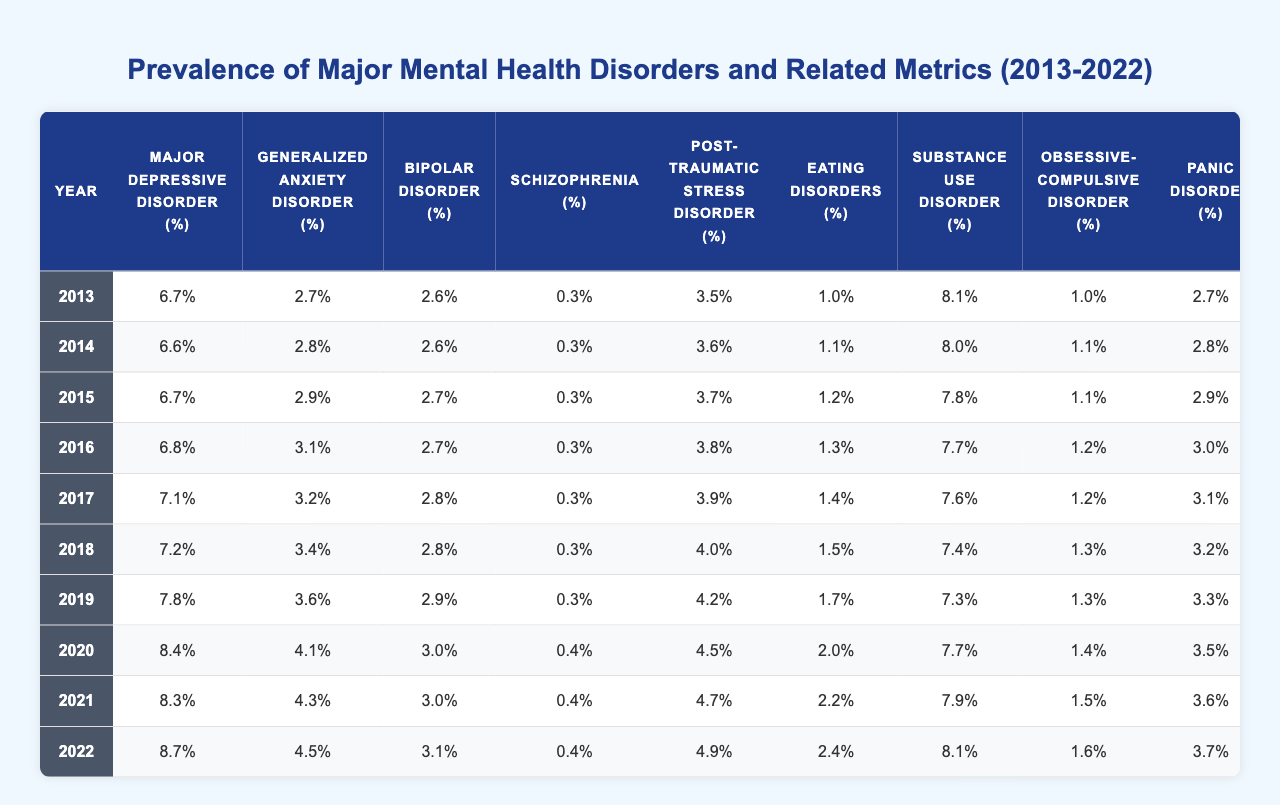What was the prevalence of Major Depressive Disorder in 2022? According to the table, the value for Major Depressive Disorder in 2022 is directly presented as 8.7%.
Answer: 8.7% In which year did Generalized Anxiety Disorder reach its highest prevalence? The table shows that Generalized Anxiety Disorder reached its highest prevalence of 4.5% in 2022.
Answer: 2022 What is the trend of Eating Disorders prevalence from 2013 to 2022? By comparing the values across the years, Eating Disorders increased from 1.0% in 2013 to 2.4% in 2022, indicating a consistent upward trend.
Answer: Increasing What percentage of the population experienced Schizophrenia in 2020? The table indicates that Schizophrenia prevalence was 0.4% in 2020.
Answer: 0.4% What was the average prevalence of Substance Use Disorder over the last decade? To compute the average, we sum the values: (8.1 + 8.0 + 7.8 + 7.7 + 7.6 + 7.4 + 7.3 + 7.7 + 7.9 + 8.1) = 78.6, then divide by 10, yielding an average of 7.86%.
Answer: 7.86% Was there a significant drop in the prevalence of Bipolar Disorder from 2013 to 2018? Reviewing the values from 2013 (2.6%) to 2018 (2.8%), there was no drop; in fact, it increased slightly.
Answer: No What is the difference in the prevalence of Panic Disorder between 2013 and 2022? The prevalence of Panic Disorder was 2.7% in 2013 and 3.7% in 2022. The difference is 3.7% - 2.7% = 1%.
Answer: 1% How many more Mental Health Professionals per 100,000 population were there in 2022 compared to 2013? The number in 2022 was 96, and in 2013 it was 78. The difference is 96 - 78 = 18 professionals per 100,000 population.
Answer: 18 Which mental health disorder had the lowest prevalence in 2019? By checking the table for 2019, the lowest prevalence was for Schizophrenia, at 0.3%.
Answer: Schizophrenia Identify any year where the overall mental health budget experienced a significant increase. Observing the table, the budget increased from 160 million USD in 2019 to 180 million USD in 2020, which is a significant increase of 20 million.
Answer: 2020 What was the percentage increase in prevalence for Generalized Anxiety Disorder from 2015 to 2022? The prevalence in 2015 was 2.9% and in 2022 it is 4.5%. Thus, the increase is 4.5% - 2.9% = 1.6%. To find the percentage increase: (1.6/2.9) * 100 ≈ 55.17%.
Answer: 55.17% 